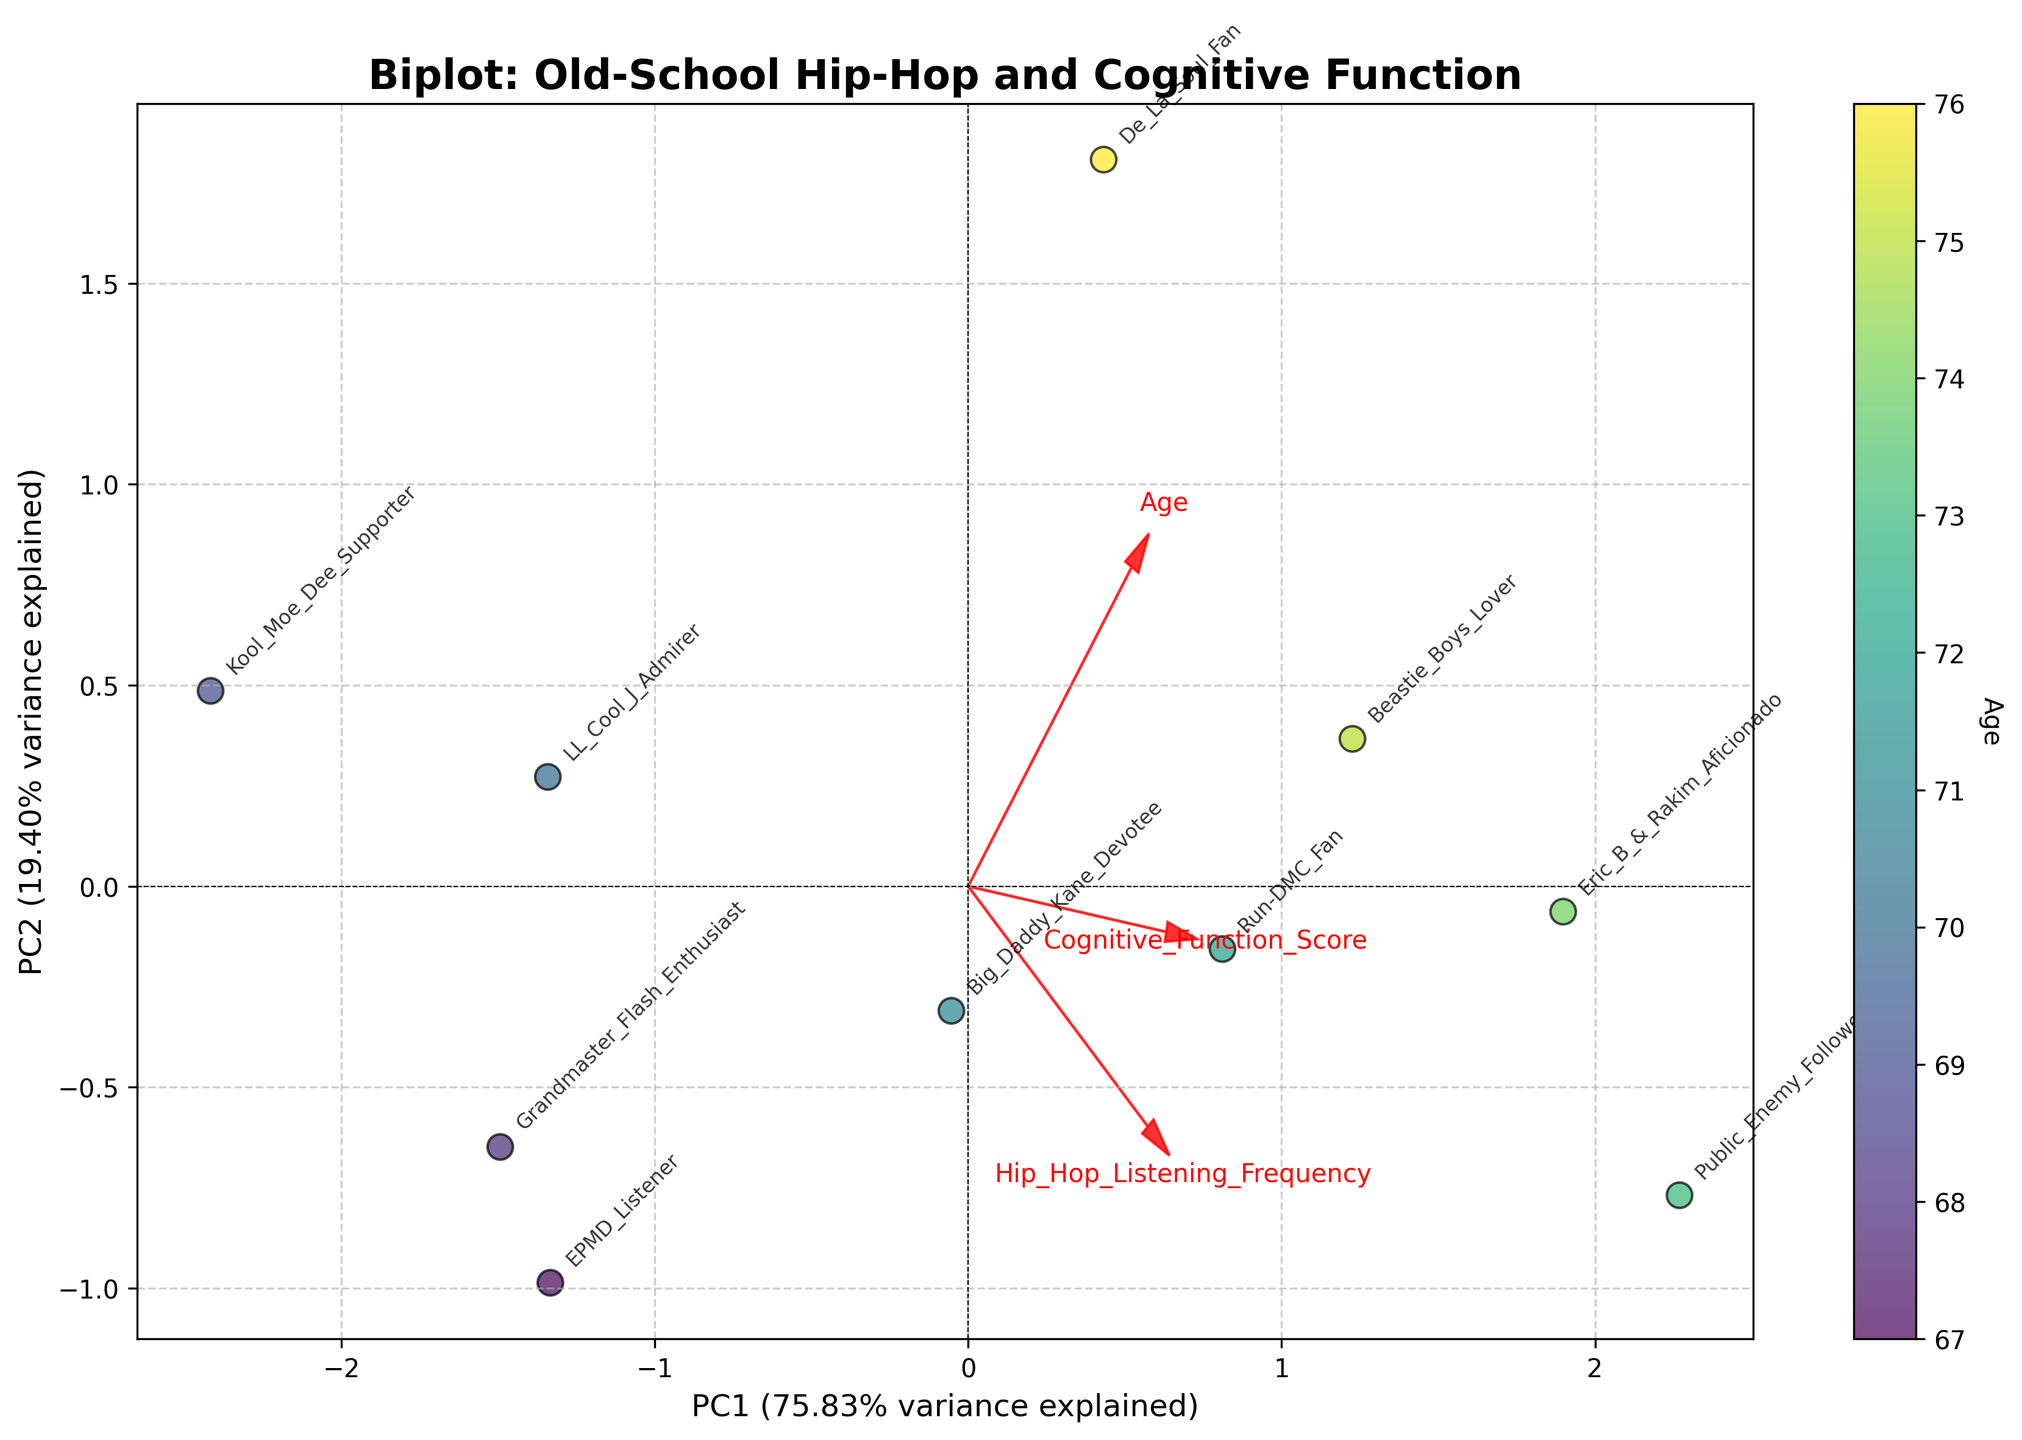What is the title of the plot? The title is prominently displayed at the top of the plot. It reads, "Biplot: Old-School Hip-Hop and Cognitive Function."
Answer: Biplot: Old-School Hip-Hop and Cognitive Function Which variable is represented by the color gradient in the scatter plot? The color gradient (from lighter to darker shades) represents the 'Age' of the individuals, as indicated by the color bar on the right side of the plot.
Answer: Age What percentage of the variance does the first principal component (PC1) explain? The x-axis label includes the variance explanation for PC1, which is given as a percentage. According to the label, PC1 explains 42.31% of the variance.
Answer: 42.31% Which data points are annotated with the name "Public_Enemy_Follower"? Each data point is labeled with a name. By examining the labels, we can see that "Public_Enemy_Follower" is located towards the upper portion of the plot, slightly to the right of center.
Answer: Upper center-right Compare the direction of the "Age" variable with the "Hip_Hop_Listening_Frequency" variable. In which directions do these vectors point? By observing the red vectors representing variables, we can see that the "Age" vector points towards the bottom-left, while the "Hip_Hop_Listening_Frequency" vector points towards the upper-right.
Answer: Opposite directions Which two individuals have the same cognitive function score, and what is that score? By checking the cognitive function scores annotated for each individual, we can observe that "De_La_Soul_Fan" and "Eric_B_&_Rakim_Aficionado" both have a score of 87.
Answer: De_La_Soul_Fan and Eric_B_&_Rakim_Aficionado, 87 How does the vector for "Cognitive_Function_Score" relate to the PC1 axis? The red arrow representing "Cognitive_Function_Score" is closely aligned with the PC1 axis, indicating a strong correlation with this principal component.
Answer: Closely aligned Among the listed individuals, who exhibits the highest frequency of listening to old-school hip-hop, and how does this relate to their cognitive function score? By reviewing the data points and labels, we can see "Public_Enemy_Follower" has the highest frequency of 9. Their cognitive function score, located in the upper portion of the plot, is among the highest at 88.
Answer: Public_Enemy_Follower; high cognitive function score What is the overall trend between "Hip_Hop_Listening_Frequency" and "Cognitive_Function_Score" as indicated by the biplot? The biplot vectors suggest that "Hip_Hop_Listening_Frequency" and "Cognitive_Function_Score" point in similar directions, indicating a positive correlation between these two variables. As one increases, the other tends to increase as well.
Answer: Positive correlation 